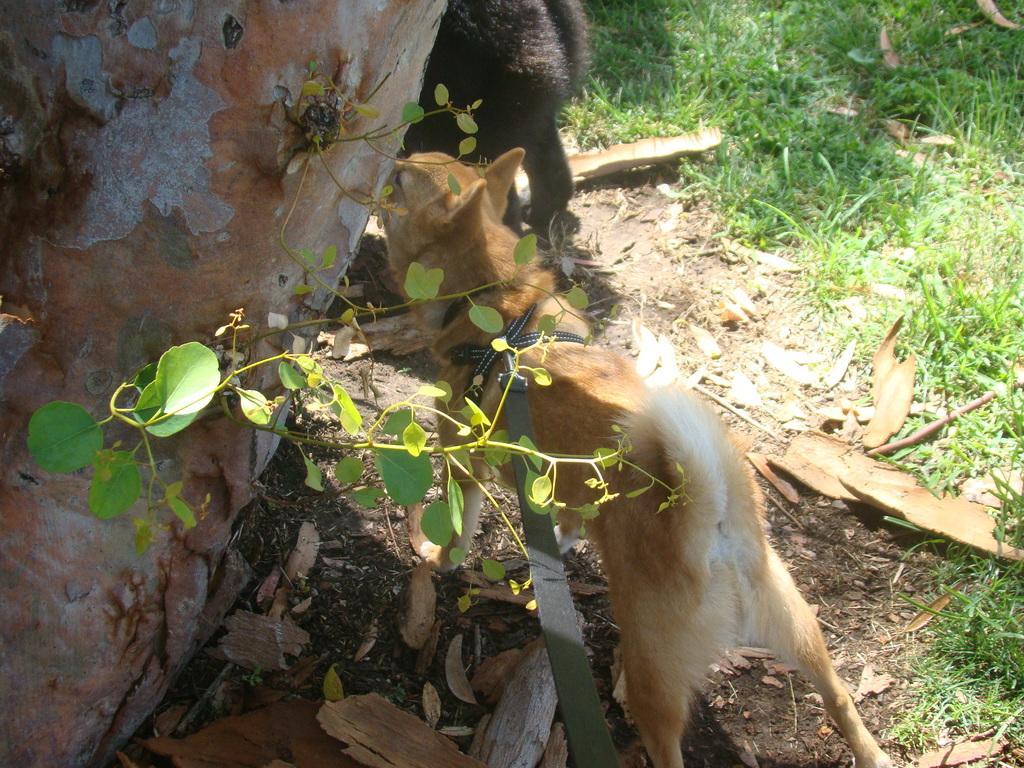Can you describe this image briefly? Here we can see a dog standing on the ground and there is a belt tied to its body. On the left there is a truncated tree. We can see an animal,grass and leaves on the ground. 